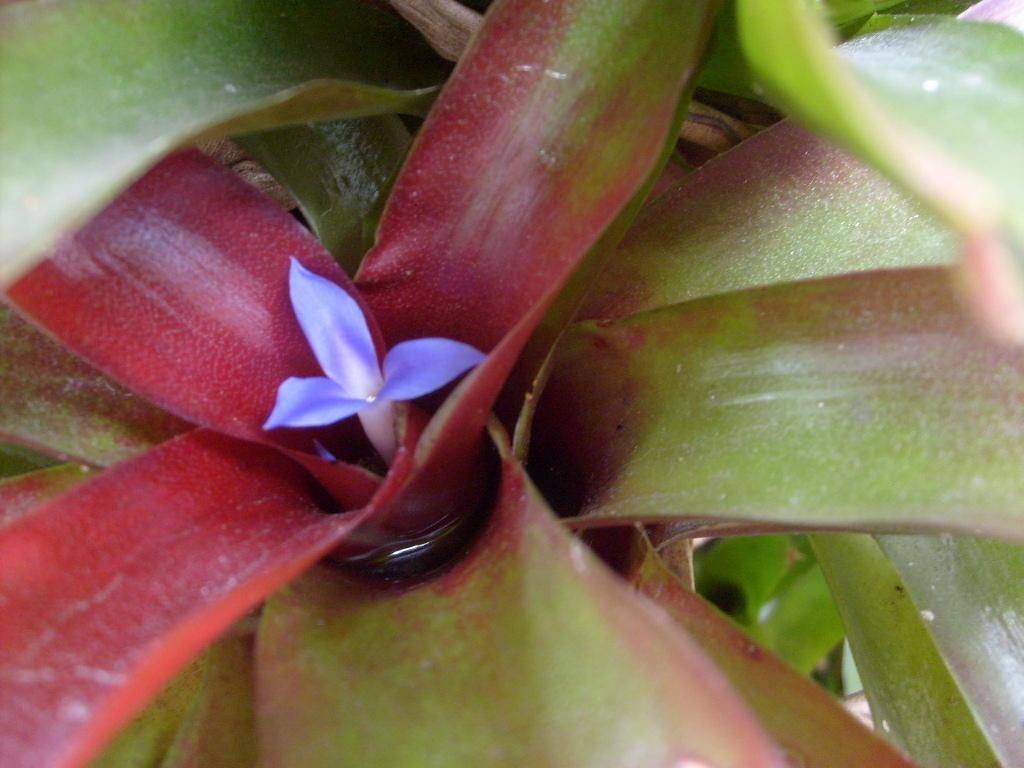What type of plant is featured in the image? The image contains leaves of a plant. Can you describe the main element in the center of the image? There is a flower in the center of the image. What type of animal can be seen learning to read in the image? There is no animal present in the image, and no learning or reading activity is depicted. 